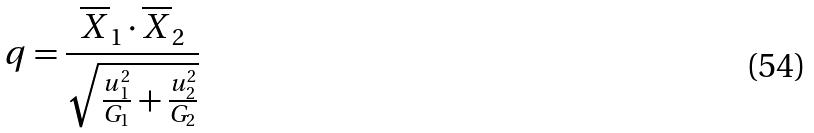Convert formula to latex. <formula><loc_0><loc_0><loc_500><loc_500>q = \frac { \overline { X } _ { 1 } \cdot \overline { X } _ { 2 } } { \sqrt { \frac { u _ { 1 } ^ { 2 } } { G _ { 1 } } + \frac { u _ { 2 } ^ { 2 } } { G _ { 2 } } } }</formula> 